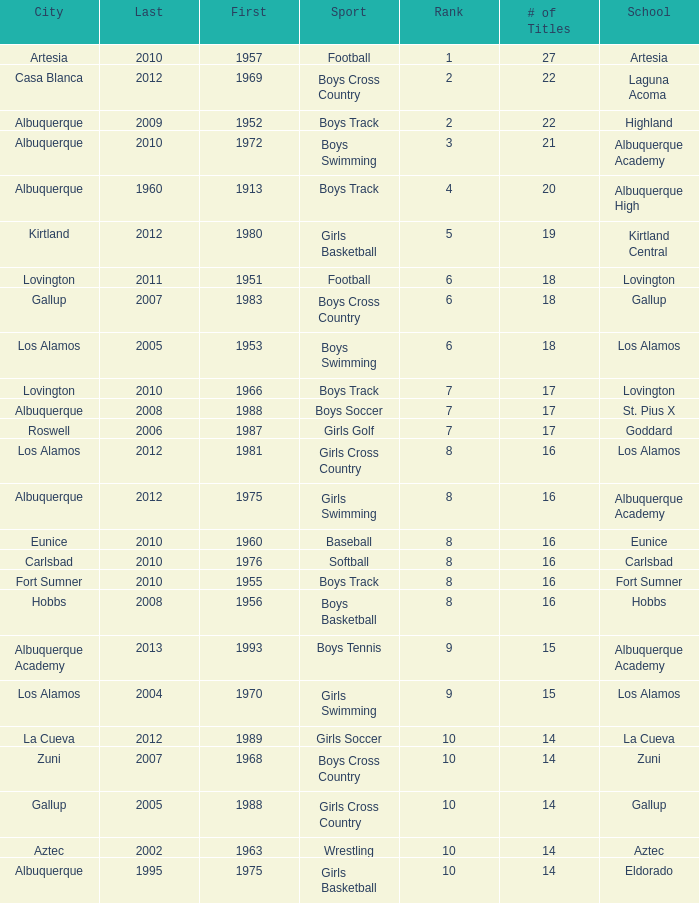What city is the School, Highland, in that ranks less than 8 and had its first title before 1980 and its last title later than 1960? Albuquerque. 